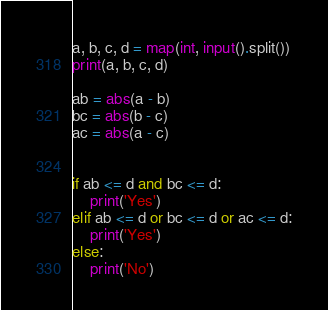<code> <loc_0><loc_0><loc_500><loc_500><_Python_>a, b, c, d = map(int, input().split())
print(a, b, c, d)

ab = abs(a - b)
bc = abs(b - c)
ac = abs(a - c)


if ab <= d and bc <= d:
    print('Yes')
elif ab <= d or bc <= d or ac <= d:
    print('Yes')
else:
    print('No')</code> 